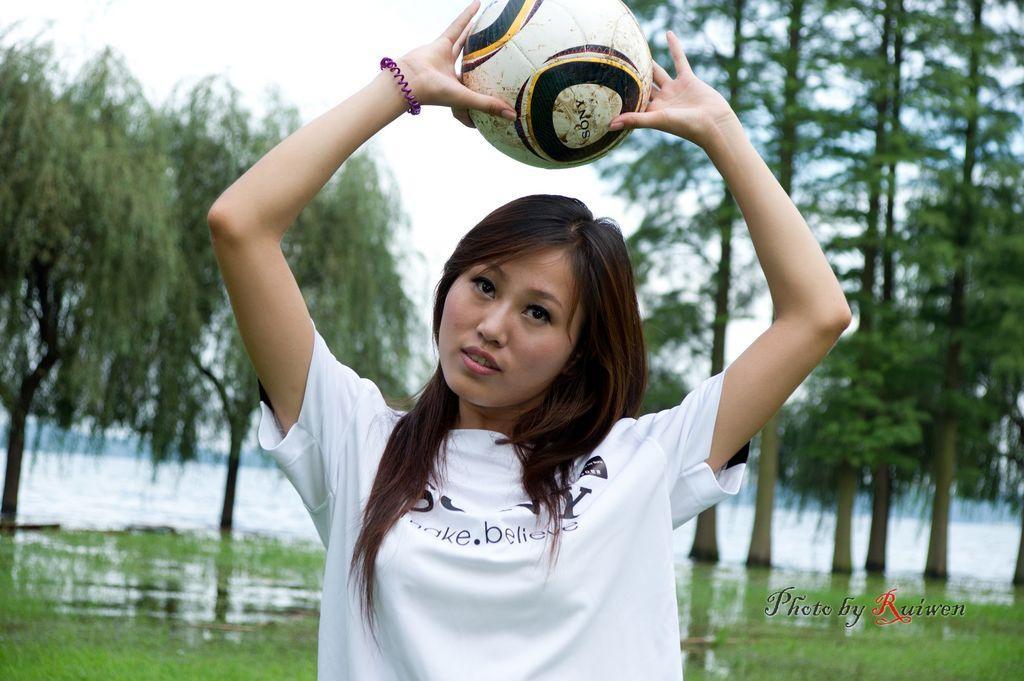Could you give a brief overview of what you see in this image? This image is clicked outside. there is on the top. There are on the left side and right side. There is grass in the bottom and there is water behind that grass. There is a woman standing in the middle, she is wearing white color t-shirt and she is holding a ball in her hand. 